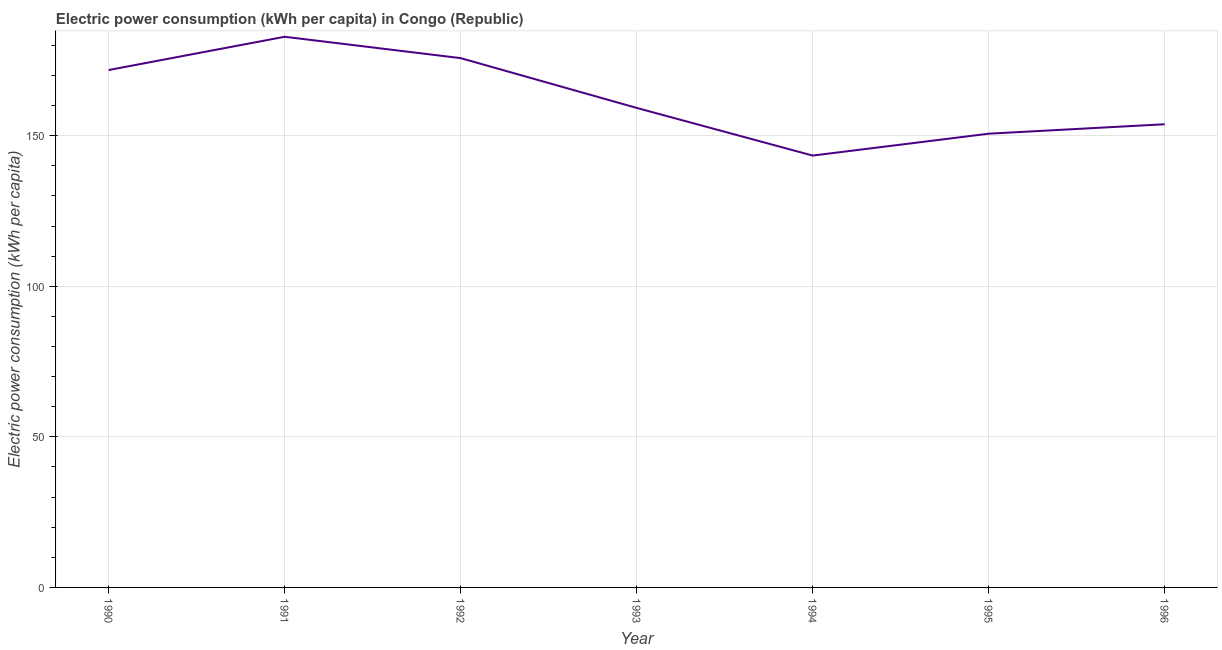What is the electric power consumption in 1992?
Your response must be concise. 175.75. Across all years, what is the maximum electric power consumption?
Provide a succinct answer. 182.85. Across all years, what is the minimum electric power consumption?
Offer a terse response. 143.4. In which year was the electric power consumption maximum?
Provide a short and direct response. 1991. What is the sum of the electric power consumption?
Ensure brevity in your answer.  1137.48. What is the difference between the electric power consumption in 1994 and 1995?
Make the answer very short. -7.27. What is the average electric power consumption per year?
Your response must be concise. 162.5. What is the median electric power consumption?
Give a very brief answer. 159.22. In how many years, is the electric power consumption greater than 70 kWh per capita?
Your answer should be very brief. 7. Do a majority of the years between 1995 and 1996 (inclusive) have electric power consumption greater than 140 kWh per capita?
Offer a terse response. Yes. What is the ratio of the electric power consumption in 1991 to that in 1994?
Provide a short and direct response. 1.28. What is the difference between the highest and the second highest electric power consumption?
Provide a succinct answer. 7.1. What is the difference between the highest and the lowest electric power consumption?
Provide a succinct answer. 39.45. In how many years, is the electric power consumption greater than the average electric power consumption taken over all years?
Your response must be concise. 3. Does the electric power consumption monotonically increase over the years?
Offer a terse response. No. Are the values on the major ticks of Y-axis written in scientific E-notation?
Give a very brief answer. No. Does the graph contain any zero values?
Your response must be concise. No. Does the graph contain grids?
Provide a short and direct response. Yes. What is the title of the graph?
Give a very brief answer. Electric power consumption (kWh per capita) in Congo (Republic). What is the label or title of the Y-axis?
Your response must be concise. Electric power consumption (kWh per capita). What is the Electric power consumption (kWh per capita) of 1990?
Offer a terse response. 171.8. What is the Electric power consumption (kWh per capita) of 1991?
Offer a very short reply. 182.85. What is the Electric power consumption (kWh per capita) of 1992?
Provide a succinct answer. 175.75. What is the Electric power consumption (kWh per capita) in 1993?
Your answer should be compact. 159.22. What is the Electric power consumption (kWh per capita) of 1994?
Give a very brief answer. 143.4. What is the Electric power consumption (kWh per capita) in 1995?
Provide a succinct answer. 150.66. What is the Electric power consumption (kWh per capita) in 1996?
Offer a very short reply. 153.8. What is the difference between the Electric power consumption (kWh per capita) in 1990 and 1991?
Make the answer very short. -11.05. What is the difference between the Electric power consumption (kWh per capita) in 1990 and 1992?
Your response must be concise. -3.95. What is the difference between the Electric power consumption (kWh per capita) in 1990 and 1993?
Your answer should be compact. 12.58. What is the difference between the Electric power consumption (kWh per capita) in 1990 and 1994?
Your response must be concise. 28.4. What is the difference between the Electric power consumption (kWh per capita) in 1990 and 1995?
Your answer should be compact. 21.14. What is the difference between the Electric power consumption (kWh per capita) in 1990 and 1996?
Make the answer very short. 18.01. What is the difference between the Electric power consumption (kWh per capita) in 1991 and 1992?
Your answer should be very brief. 7.1. What is the difference between the Electric power consumption (kWh per capita) in 1991 and 1993?
Provide a short and direct response. 23.63. What is the difference between the Electric power consumption (kWh per capita) in 1991 and 1994?
Your answer should be very brief. 39.45. What is the difference between the Electric power consumption (kWh per capita) in 1991 and 1995?
Provide a short and direct response. 32.18. What is the difference between the Electric power consumption (kWh per capita) in 1991 and 1996?
Keep it short and to the point. 29.05. What is the difference between the Electric power consumption (kWh per capita) in 1992 and 1993?
Ensure brevity in your answer.  16.53. What is the difference between the Electric power consumption (kWh per capita) in 1992 and 1994?
Provide a short and direct response. 32.35. What is the difference between the Electric power consumption (kWh per capita) in 1992 and 1995?
Ensure brevity in your answer.  25.09. What is the difference between the Electric power consumption (kWh per capita) in 1992 and 1996?
Your response must be concise. 21.96. What is the difference between the Electric power consumption (kWh per capita) in 1993 and 1994?
Offer a very short reply. 15.82. What is the difference between the Electric power consumption (kWh per capita) in 1993 and 1995?
Ensure brevity in your answer.  8.56. What is the difference between the Electric power consumption (kWh per capita) in 1993 and 1996?
Your answer should be very brief. 5.43. What is the difference between the Electric power consumption (kWh per capita) in 1994 and 1995?
Ensure brevity in your answer.  -7.27. What is the difference between the Electric power consumption (kWh per capita) in 1994 and 1996?
Your answer should be compact. -10.4. What is the difference between the Electric power consumption (kWh per capita) in 1995 and 1996?
Provide a succinct answer. -3.13. What is the ratio of the Electric power consumption (kWh per capita) in 1990 to that in 1993?
Make the answer very short. 1.08. What is the ratio of the Electric power consumption (kWh per capita) in 1990 to that in 1994?
Give a very brief answer. 1.2. What is the ratio of the Electric power consumption (kWh per capita) in 1990 to that in 1995?
Your response must be concise. 1.14. What is the ratio of the Electric power consumption (kWh per capita) in 1990 to that in 1996?
Give a very brief answer. 1.12. What is the ratio of the Electric power consumption (kWh per capita) in 1991 to that in 1993?
Offer a terse response. 1.15. What is the ratio of the Electric power consumption (kWh per capita) in 1991 to that in 1994?
Your response must be concise. 1.27. What is the ratio of the Electric power consumption (kWh per capita) in 1991 to that in 1995?
Ensure brevity in your answer.  1.21. What is the ratio of the Electric power consumption (kWh per capita) in 1991 to that in 1996?
Make the answer very short. 1.19. What is the ratio of the Electric power consumption (kWh per capita) in 1992 to that in 1993?
Your answer should be very brief. 1.1. What is the ratio of the Electric power consumption (kWh per capita) in 1992 to that in 1994?
Ensure brevity in your answer.  1.23. What is the ratio of the Electric power consumption (kWh per capita) in 1992 to that in 1995?
Give a very brief answer. 1.17. What is the ratio of the Electric power consumption (kWh per capita) in 1992 to that in 1996?
Provide a short and direct response. 1.14. What is the ratio of the Electric power consumption (kWh per capita) in 1993 to that in 1994?
Provide a succinct answer. 1.11. What is the ratio of the Electric power consumption (kWh per capita) in 1993 to that in 1995?
Offer a terse response. 1.06. What is the ratio of the Electric power consumption (kWh per capita) in 1993 to that in 1996?
Give a very brief answer. 1.03. What is the ratio of the Electric power consumption (kWh per capita) in 1994 to that in 1995?
Provide a succinct answer. 0.95. What is the ratio of the Electric power consumption (kWh per capita) in 1994 to that in 1996?
Ensure brevity in your answer.  0.93. What is the ratio of the Electric power consumption (kWh per capita) in 1995 to that in 1996?
Give a very brief answer. 0.98. 